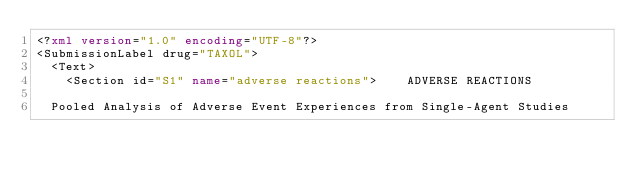<code> <loc_0><loc_0><loc_500><loc_500><_XML_><?xml version="1.0" encoding="UTF-8"?>
<SubmissionLabel drug="TAXOL">
  <Text>
    <Section id="S1" name="adverse reactions">    ADVERSE REACTIONS

  Pooled Analysis of Adverse Event Experiences from Single-Agent Studies
</code> 